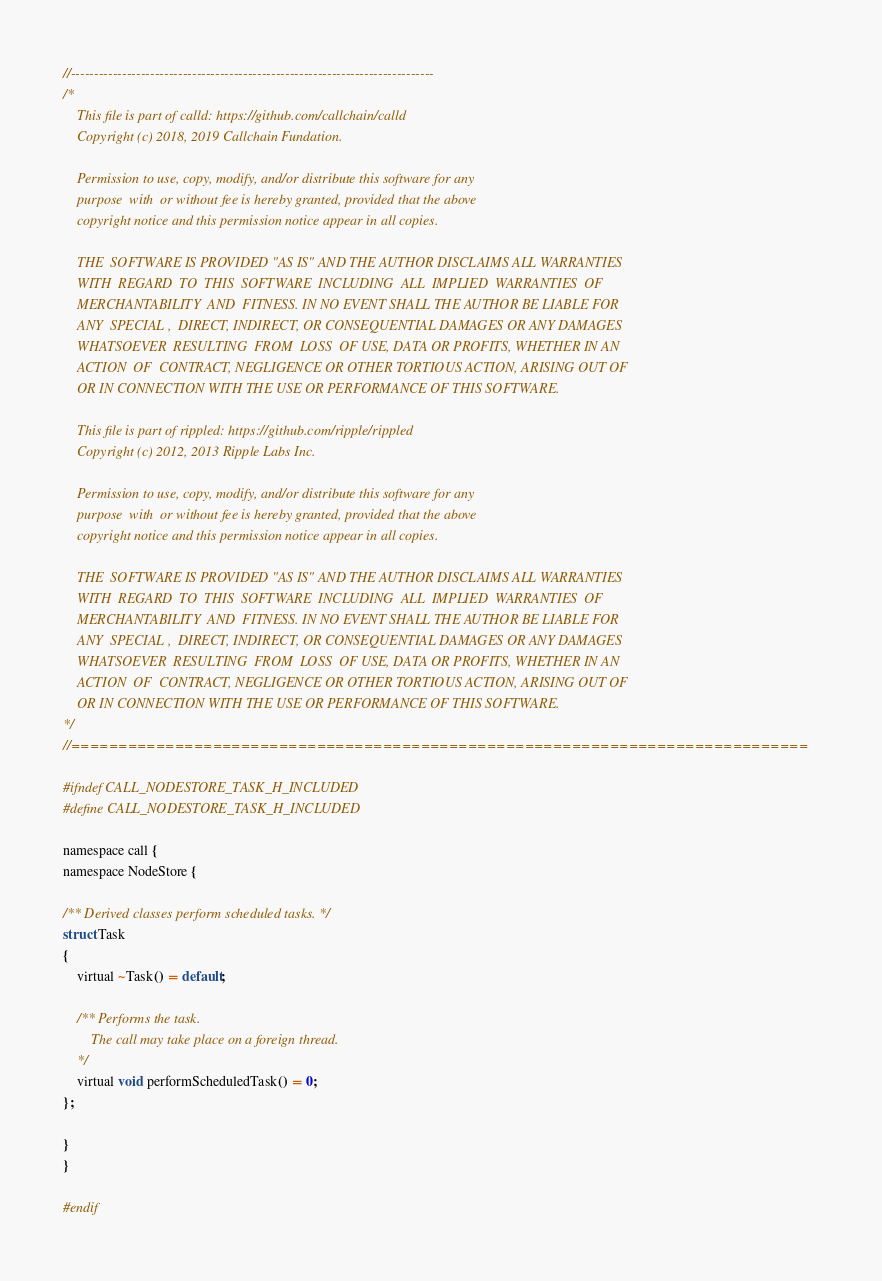Convert code to text. <code><loc_0><loc_0><loc_500><loc_500><_C_>//------------------------------------------------------------------------------
/*
    This file is part of calld: https://github.com/callchain/calld
    Copyright (c) 2018, 2019 Callchain Fundation.

    Permission to use, copy, modify, and/or distribute this software for any
    purpose  with  or without fee is hereby granted, provided that the above
    copyright notice and this permission notice appear in all copies.

    THE  SOFTWARE IS PROVIDED "AS IS" AND THE AUTHOR DISCLAIMS ALL WARRANTIES
    WITH  REGARD  TO  THIS  SOFTWARE  INCLUDING  ALL  IMPLIED  WARRANTIES  OF
    MERCHANTABILITY  AND  FITNESS. IN NO EVENT SHALL THE AUTHOR BE LIABLE FOR
    ANY  SPECIAL ,  DIRECT, INDIRECT, OR CONSEQUENTIAL DAMAGES OR ANY DAMAGES
    WHATSOEVER  RESULTING  FROM  LOSS  OF USE, DATA OR PROFITS, WHETHER IN AN
    ACTION  OF  CONTRACT, NEGLIGENCE OR OTHER TORTIOUS ACTION, ARISING OUT OF
    OR IN CONNECTION WITH THE USE OR PERFORMANCE OF THIS SOFTWARE.

    This file is part of rippled: https://github.com/ripple/rippled
    Copyright (c) 2012, 2013 Ripple Labs Inc.

    Permission to use, copy, modify, and/or distribute this software for any
    purpose  with  or without fee is hereby granted, provided that the above
    copyright notice and this permission notice appear in all copies.

    THE  SOFTWARE IS PROVIDED "AS IS" AND THE AUTHOR DISCLAIMS ALL WARRANTIES
    WITH  REGARD  TO  THIS  SOFTWARE  INCLUDING  ALL  IMPLIED  WARRANTIES  OF
    MERCHANTABILITY  AND  FITNESS. IN NO EVENT SHALL THE AUTHOR BE LIABLE FOR
    ANY  SPECIAL ,  DIRECT, INDIRECT, OR CONSEQUENTIAL DAMAGES OR ANY DAMAGES
    WHATSOEVER  RESULTING  FROM  LOSS  OF USE, DATA OR PROFITS, WHETHER IN AN
    ACTION  OF  CONTRACT, NEGLIGENCE OR OTHER TORTIOUS ACTION, ARISING OUT OF
    OR IN CONNECTION WITH THE USE OR PERFORMANCE OF THIS SOFTWARE.
*/
//==============================================================================

#ifndef CALL_NODESTORE_TASK_H_INCLUDED
#define CALL_NODESTORE_TASK_H_INCLUDED

namespace call {
namespace NodeStore {

/** Derived classes perform scheduled tasks. */
struct Task
{
    virtual ~Task() = default;

    /** Performs the task.
        The call may take place on a foreign thread.
    */
    virtual void performScheduledTask() = 0;
};

}
}

#endif
</code> 